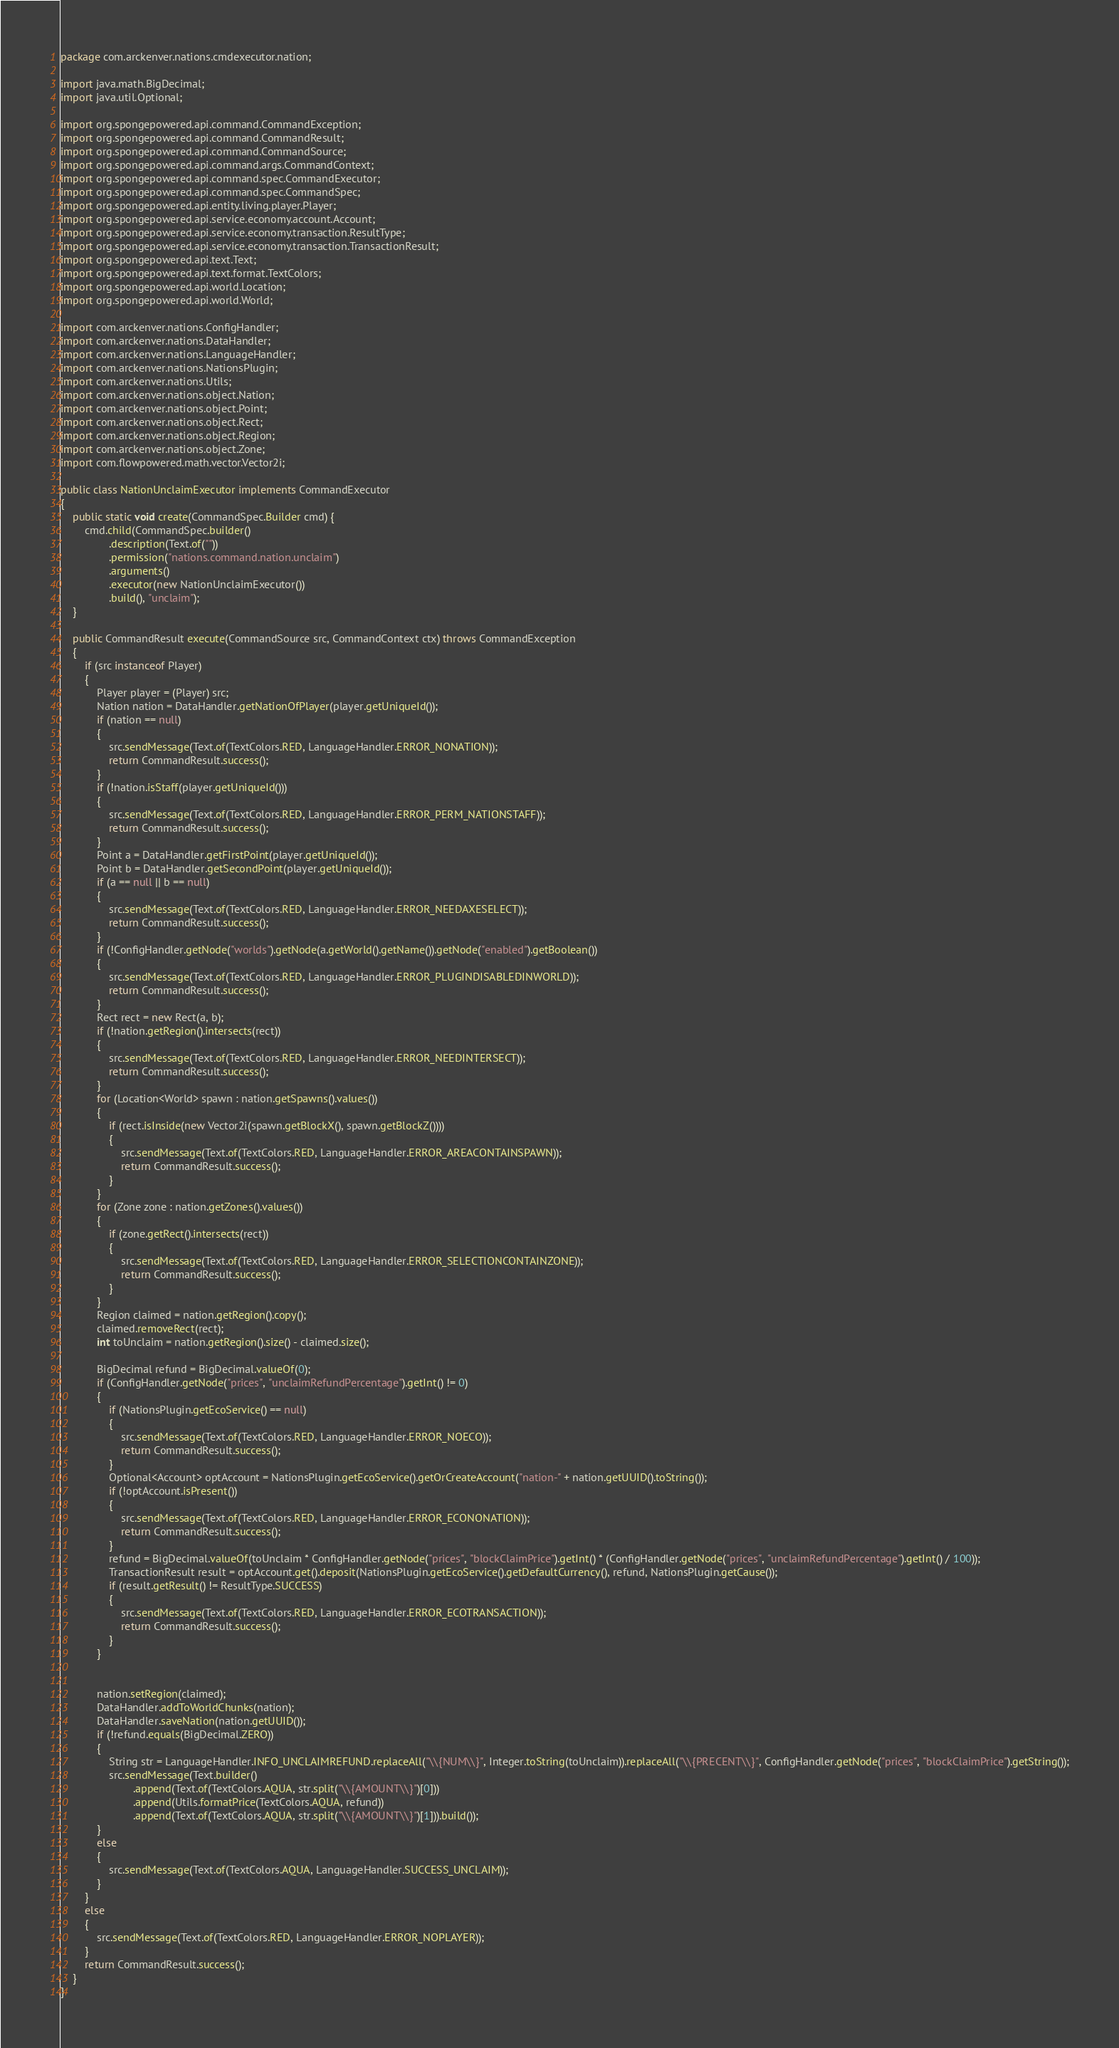<code> <loc_0><loc_0><loc_500><loc_500><_Java_>package com.arckenver.nations.cmdexecutor.nation;

import java.math.BigDecimal;
import java.util.Optional;

import org.spongepowered.api.command.CommandException;
import org.spongepowered.api.command.CommandResult;
import org.spongepowered.api.command.CommandSource;
import org.spongepowered.api.command.args.CommandContext;
import org.spongepowered.api.command.spec.CommandExecutor;
import org.spongepowered.api.command.spec.CommandSpec;
import org.spongepowered.api.entity.living.player.Player;
import org.spongepowered.api.service.economy.account.Account;
import org.spongepowered.api.service.economy.transaction.ResultType;
import org.spongepowered.api.service.economy.transaction.TransactionResult;
import org.spongepowered.api.text.Text;
import org.spongepowered.api.text.format.TextColors;
import org.spongepowered.api.world.Location;
import org.spongepowered.api.world.World;

import com.arckenver.nations.ConfigHandler;
import com.arckenver.nations.DataHandler;
import com.arckenver.nations.LanguageHandler;
import com.arckenver.nations.NationsPlugin;
import com.arckenver.nations.Utils;
import com.arckenver.nations.object.Nation;
import com.arckenver.nations.object.Point;
import com.arckenver.nations.object.Rect;
import com.arckenver.nations.object.Region;
import com.arckenver.nations.object.Zone;
import com.flowpowered.math.vector.Vector2i;

public class NationUnclaimExecutor implements CommandExecutor
{
	public static void create(CommandSpec.Builder cmd) {
		cmd.child(CommandSpec.builder()
				.description(Text.of(""))
				.permission("nations.command.nation.unclaim")
				.arguments()
				.executor(new NationUnclaimExecutor())
				.build(), "unclaim");
	}

	public CommandResult execute(CommandSource src, CommandContext ctx) throws CommandException
	{
		if (src instanceof Player)
		{
			Player player = (Player) src;
			Nation nation = DataHandler.getNationOfPlayer(player.getUniqueId());
			if (nation == null)
			{
				src.sendMessage(Text.of(TextColors.RED, LanguageHandler.ERROR_NONATION));
				return CommandResult.success();
			}
			if (!nation.isStaff(player.getUniqueId()))
			{
				src.sendMessage(Text.of(TextColors.RED, LanguageHandler.ERROR_PERM_NATIONSTAFF));
				return CommandResult.success();
			}
			Point a = DataHandler.getFirstPoint(player.getUniqueId());
			Point b = DataHandler.getSecondPoint(player.getUniqueId());
			if (a == null || b == null)
			{
				src.sendMessage(Text.of(TextColors.RED, LanguageHandler.ERROR_NEEDAXESELECT));
				return CommandResult.success();
			}
			if (!ConfigHandler.getNode("worlds").getNode(a.getWorld().getName()).getNode("enabled").getBoolean())
			{
				src.sendMessage(Text.of(TextColors.RED, LanguageHandler.ERROR_PLUGINDISABLEDINWORLD));
				return CommandResult.success();
			}
			Rect rect = new Rect(a, b);
			if (!nation.getRegion().intersects(rect))
			{
				src.sendMessage(Text.of(TextColors.RED, LanguageHandler.ERROR_NEEDINTERSECT));
				return CommandResult.success();
			}
			for (Location<World> spawn : nation.getSpawns().values())
			{
				if (rect.isInside(new Vector2i(spawn.getBlockX(), spawn.getBlockZ())))
				{
					src.sendMessage(Text.of(TextColors.RED, LanguageHandler.ERROR_AREACONTAINSPAWN));
					return CommandResult.success();
				}
			}
			for (Zone zone : nation.getZones().values())
			{
				if (zone.getRect().intersects(rect))
				{
					src.sendMessage(Text.of(TextColors.RED, LanguageHandler.ERROR_SELECTIONCONTAINZONE));
					return CommandResult.success();
				}
			}
			Region claimed = nation.getRegion().copy();
			claimed.removeRect(rect);
			int toUnclaim = nation.getRegion().size() - claimed.size();
			
			BigDecimal refund = BigDecimal.valueOf(0);
			if (ConfigHandler.getNode("prices", "unclaimRefundPercentage").getInt() != 0)
			{
				if (NationsPlugin.getEcoService() == null)
				{
					src.sendMessage(Text.of(TextColors.RED, LanguageHandler.ERROR_NOECO));
					return CommandResult.success();
				}
				Optional<Account> optAccount = NationsPlugin.getEcoService().getOrCreateAccount("nation-" + nation.getUUID().toString());
				if (!optAccount.isPresent())
				{
					src.sendMessage(Text.of(TextColors.RED, LanguageHandler.ERROR_ECONONATION));
					return CommandResult.success();
				}
				refund = BigDecimal.valueOf(toUnclaim * ConfigHandler.getNode("prices", "blockClaimPrice").getInt() * (ConfigHandler.getNode("prices", "unclaimRefundPercentage").getInt() / 100));
				TransactionResult result = optAccount.get().deposit(NationsPlugin.getEcoService().getDefaultCurrency(), refund, NationsPlugin.getCause());
				if (result.getResult() != ResultType.SUCCESS)
				{
					src.sendMessage(Text.of(TextColors.RED, LanguageHandler.ERROR_ECOTRANSACTION));
					return CommandResult.success();
				}
			}
			
			
			nation.setRegion(claimed);
			DataHandler.addToWorldChunks(nation);
			DataHandler.saveNation(nation.getUUID());
			if (!refund.equals(BigDecimal.ZERO))
			{
				String str = LanguageHandler.INFO_UNCLAIMREFUND.replaceAll("\\{NUM\\}", Integer.toString(toUnclaim)).replaceAll("\\{PRECENT\\}", ConfigHandler.getNode("prices", "blockClaimPrice").getString());
				src.sendMessage(Text.builder()
						.append(Text.of(TextColors.AQUA, str.split("\\{AMOUNT\\}")[0]))
						.append(Utils.formatPrice(TextColors.AQUA, refund))
						.append(Text.of(TextColors.AQUA, str.split("\\{AMOUNT\\}")[1])).build());
			}
			else
			{
				src.sendMessage(Text.of(TextColors.AQUA, LanguageHandler.SUCCESS_UNCLAIM));
			}
		}
		else
		{
			src.sendMessage(Text.of(TextColors.RED, LanguageHandler.ERROR_NOPLAYER));
		}
		return CommandResult.success();
	}
}
</code> 